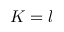<formula> <loc_0><loc_0><loc_500><loc_500>K = l</formula> 